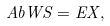<formula> <loc_0><loc_0><loc_500><loc_500>\ A b { W } { S } = E X ,</formula> 